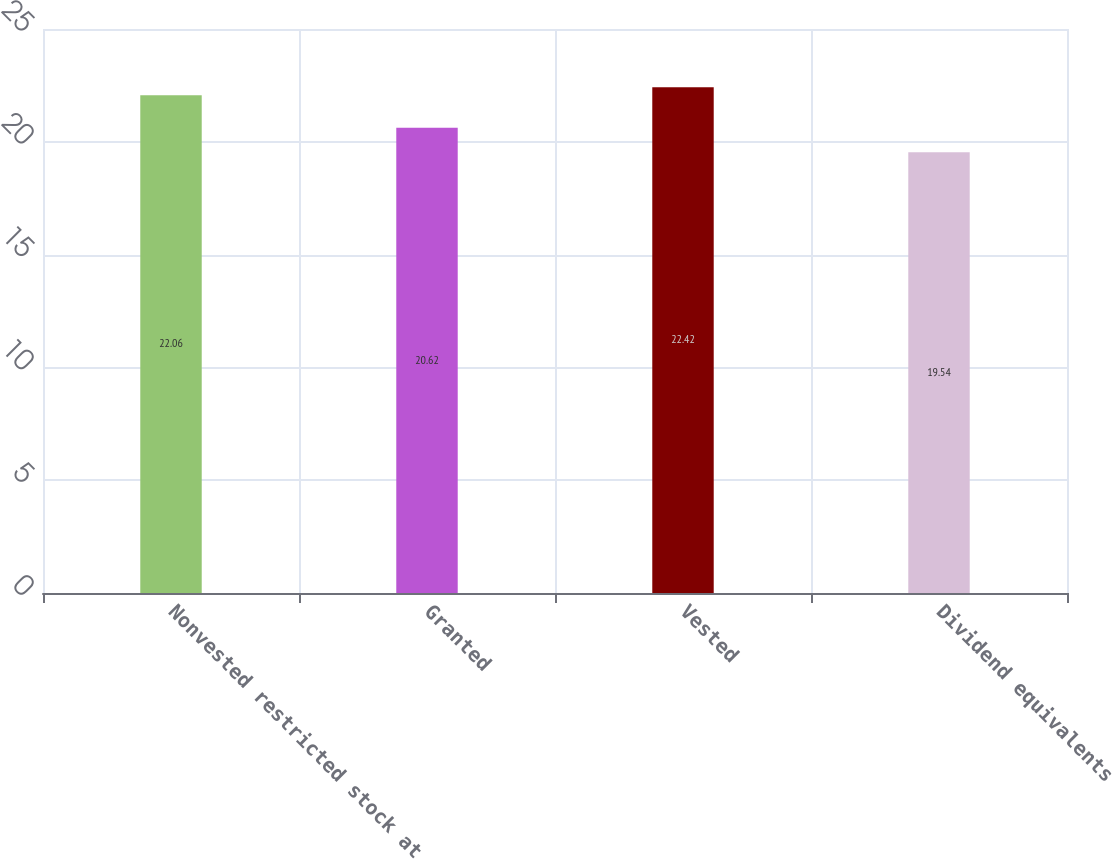Convert chart to OTSL. <chart><loc_0><loc_0><loc_500><loc_500><bar_chart><fcel>Nonvested restricted stock at<fcel>Granted<fcel>Vested<fcel>Dividend equivalents<nl><fcel>22.06<fcel>20.62<fcel>22.42<fcel>19.54<nl></chart> 